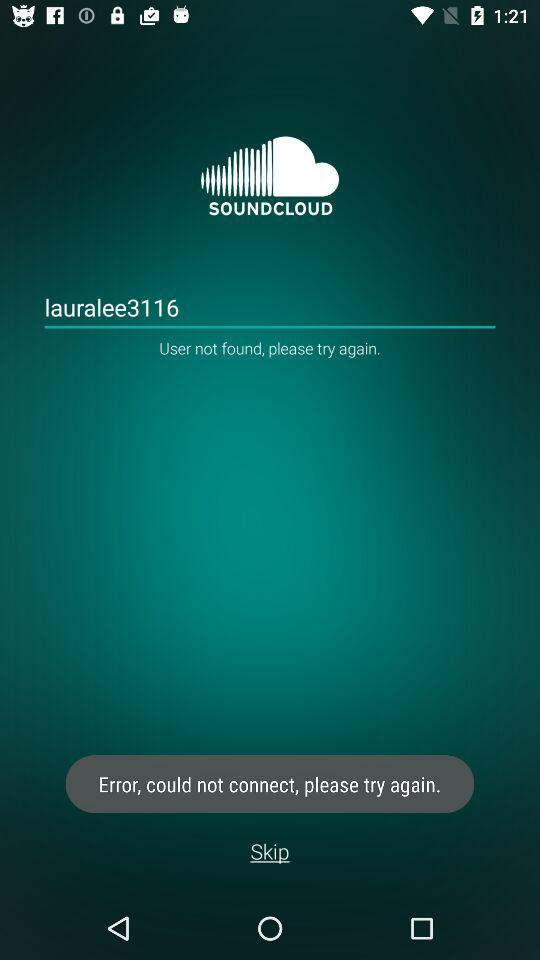What is the application name? The application name is "SOUNDCLOUD". 